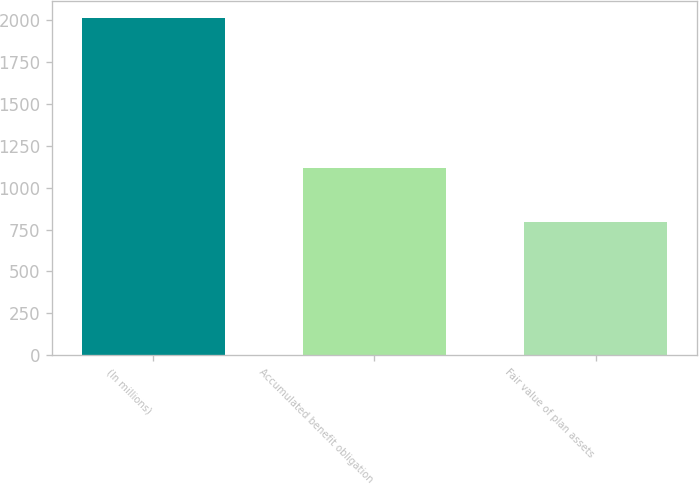Convert chart to OTSL. <chart><loc_0><loc_0><loc_500><loc_500><bar_chart><fcel>(In millions)<fcel>Accumulated benefit obligation<fcel>Fair value of plan assets<nl><fcel>2012<fcel>1120.2<fcel>793.1<nl></chart> 